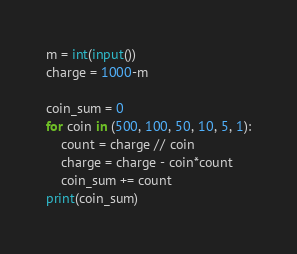Convert code to text. <code><loc_0><loc_0><loc_500><loc_500><_Python_>m = int(input())
charge = 1000-m

coin_sum = 0
for coin in (500, 100, 50, 10, 5, 1):
    count = charge // coin
    charge = charge - coin*count
    coin_sum += count
print(coin_sum)
</code> 